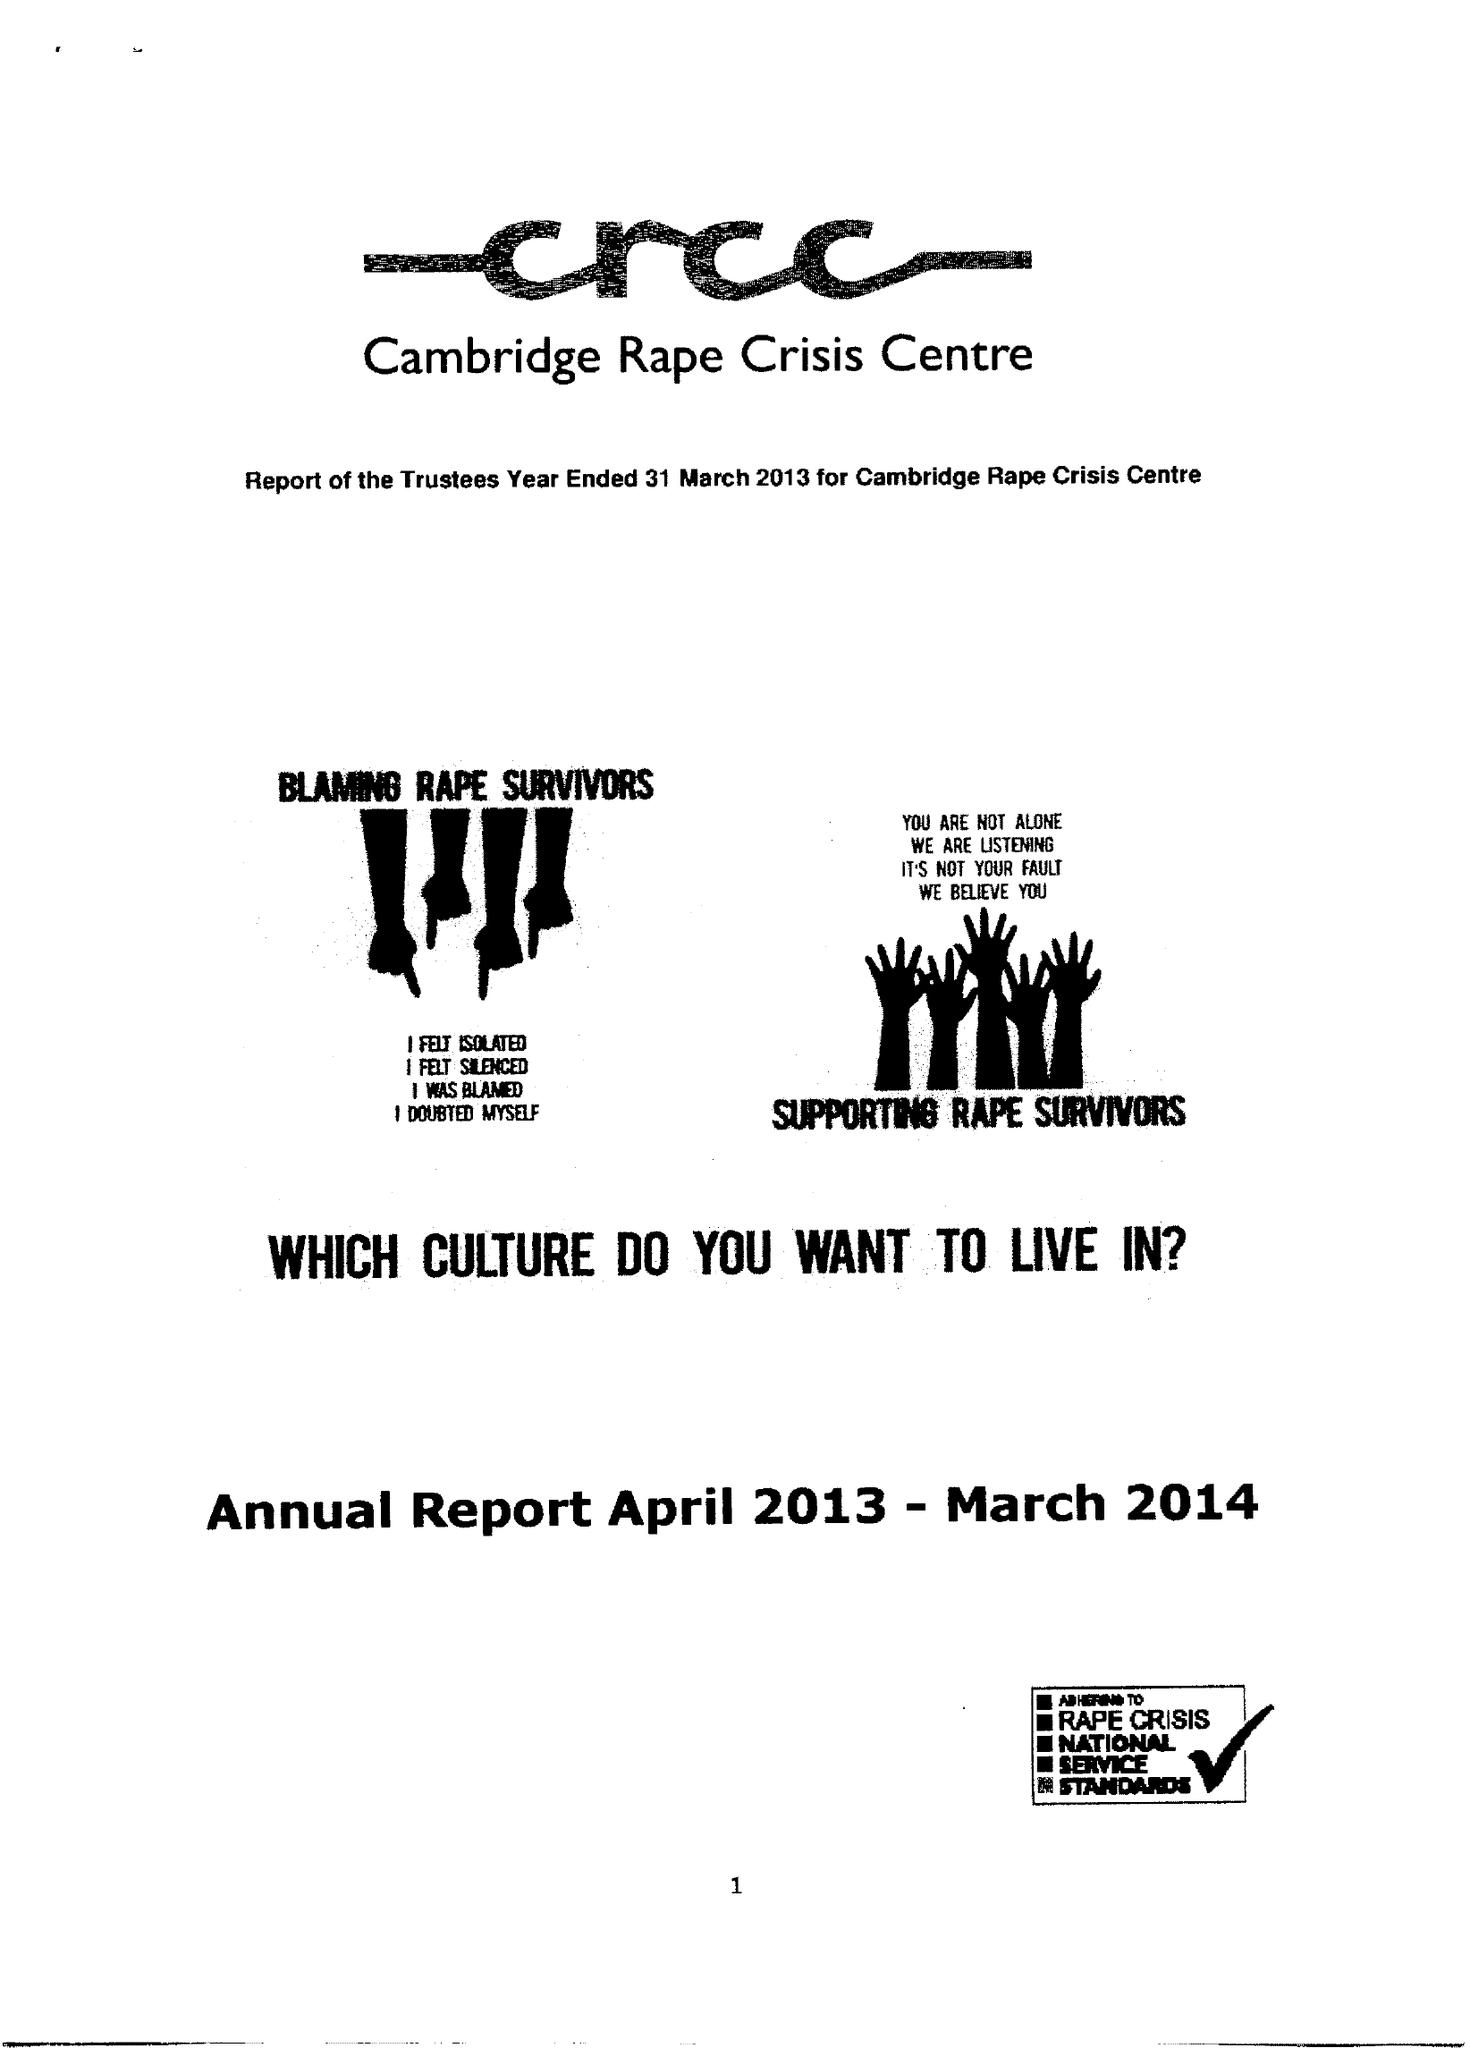What is the value for the address__postcode?
Answer the question using a single word or phrase. CB1 2AD 